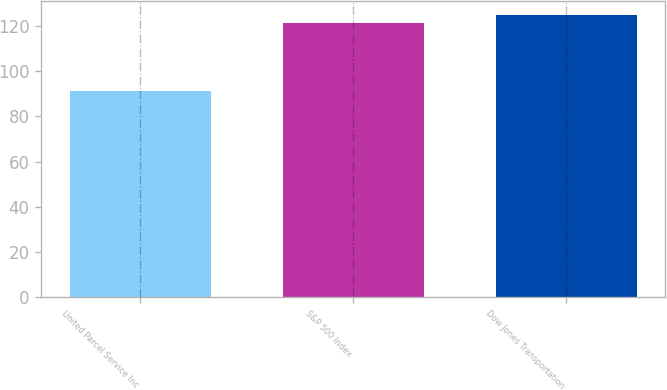Convert chart to OTSL. <chart><loc_0><loc_0><loc_500><loc_500><bar_chart><fcel>United Parcel Service Inc<fcel>S&P 500 Index<fcel>Dow Jones Transportation<nl><fcel>91.06<fcel>121.48<fcel>124.64<nl></chart> 